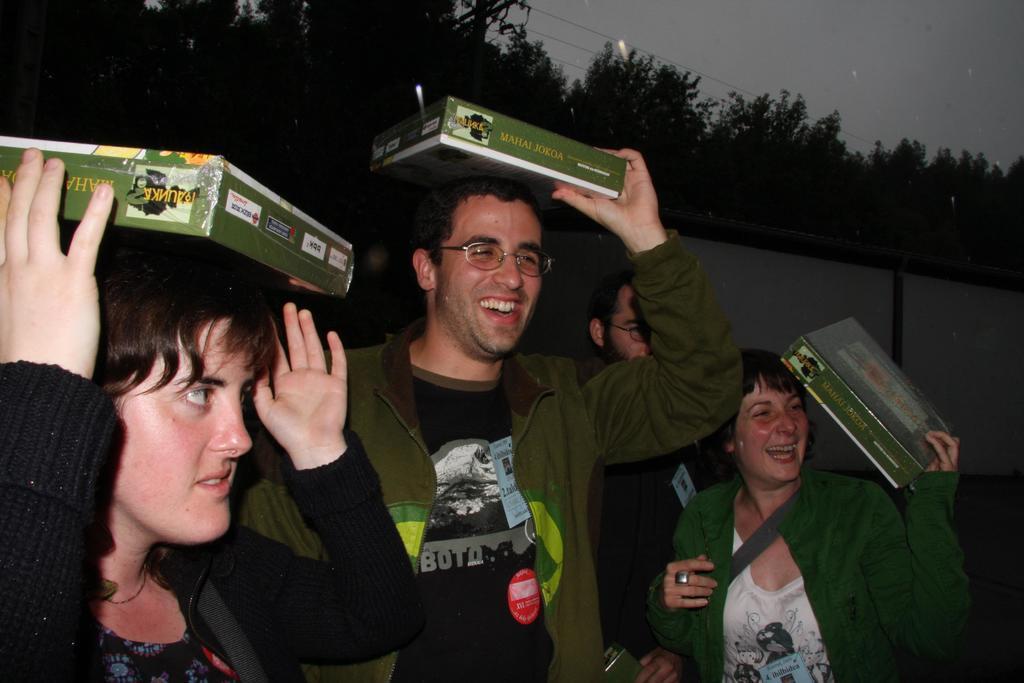Could you give a brief overview of what you see in this image? In this image we can see people standing and holding cartons. In the background there are trees, wires and sky. 